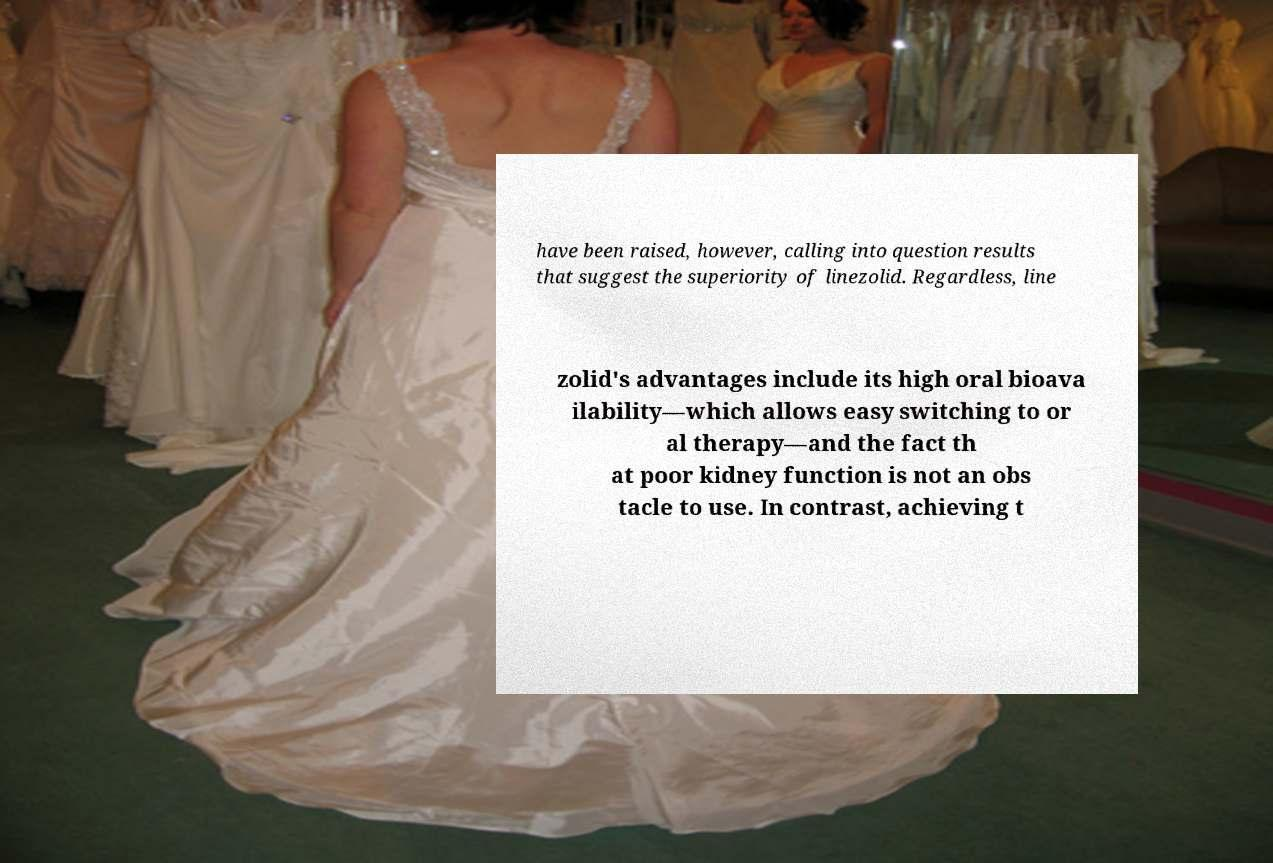I need the written content from this picture converted into text. Can you do that? have been raised, however, calling into question results that suggest the superiority of linezolid. Regardless, line zolid's advantages include its high oral bioava ilability—which allows easy switching to or al therapy—and the fact th at poor kidney function is not an obs tacle to use. In contrast, achieving t 